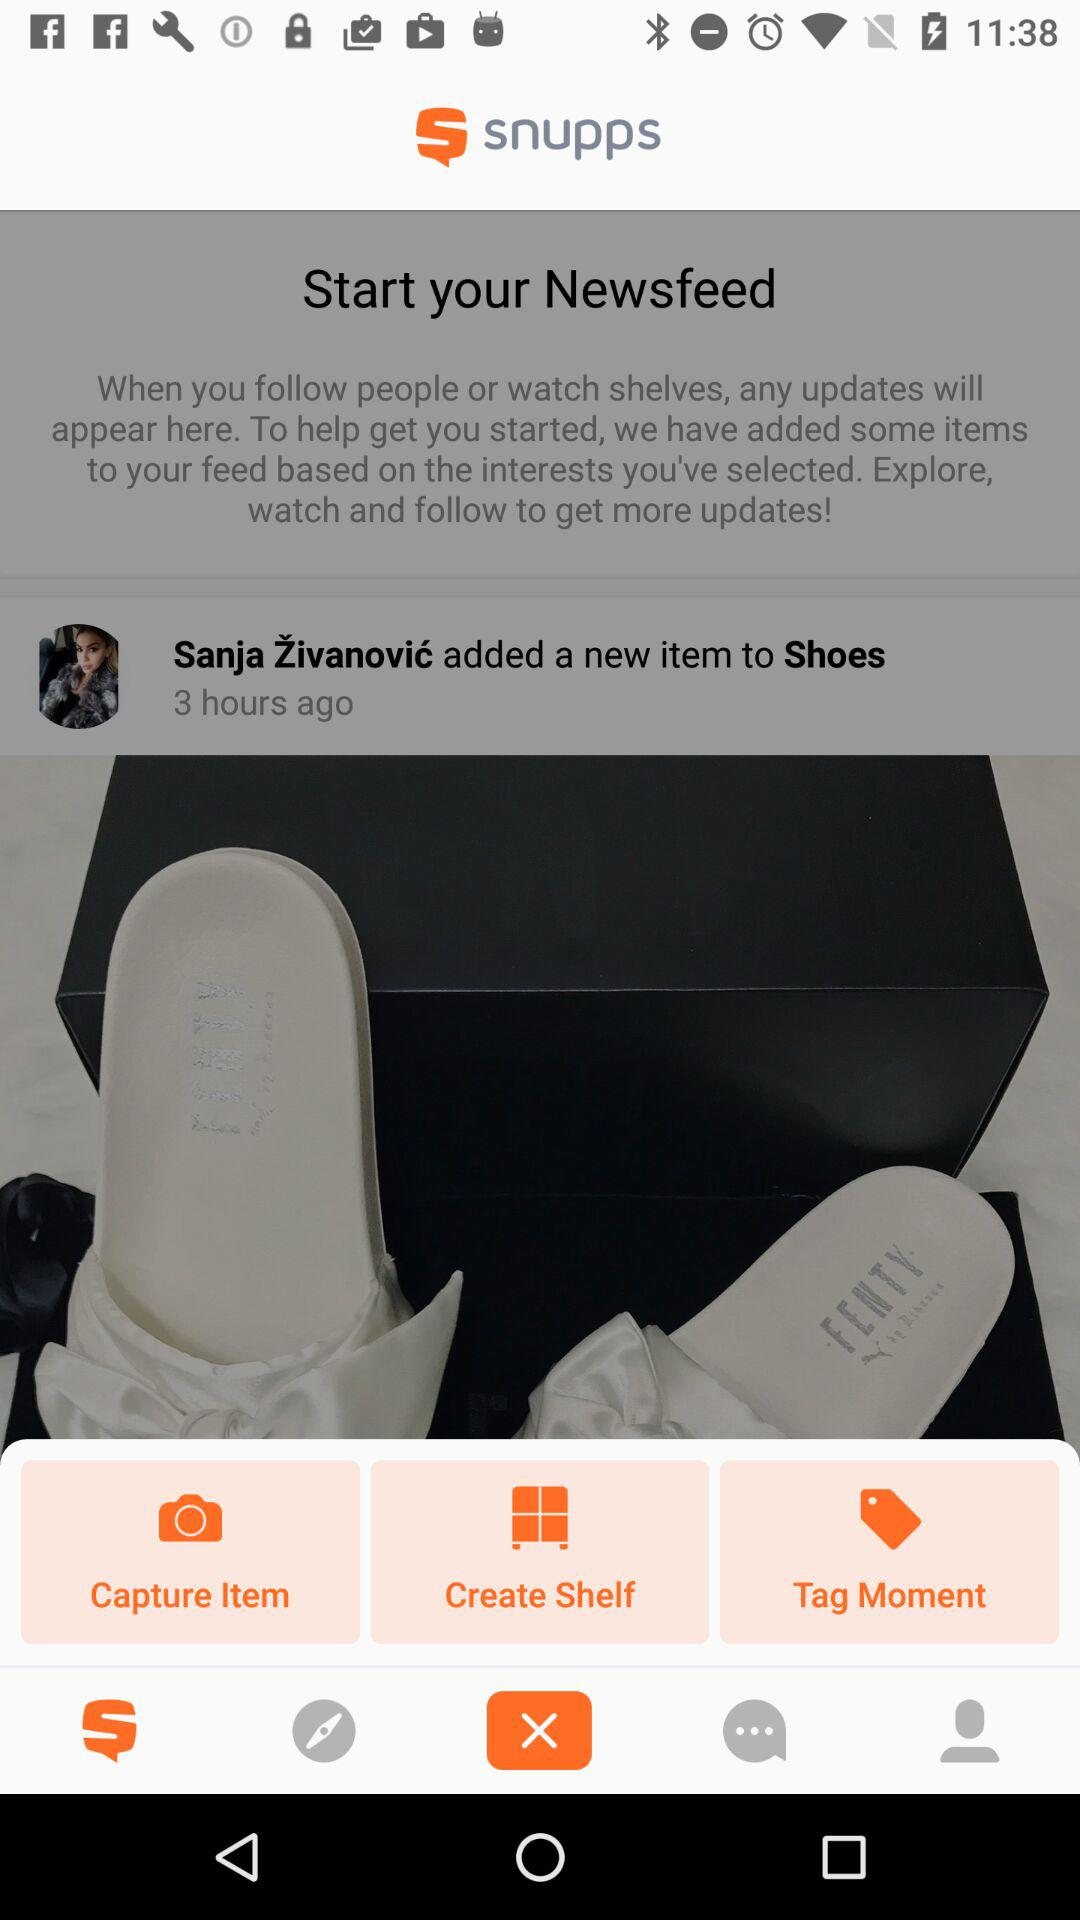How long ago was this post posted? This post was posted 3 hours ago. 